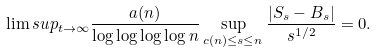<formula> <loc_0><loc_0><loc_500><loc_500>\lim s u p _ { t \to \infty } \frac { a ( n ) } { \log \log \log \log n } \sup _ { c ( n ) \leq s \leq n } \frac { | S _ { s } - B _ { s } | } { s ^ { 1 / 2 } } = 0 .</formula> 